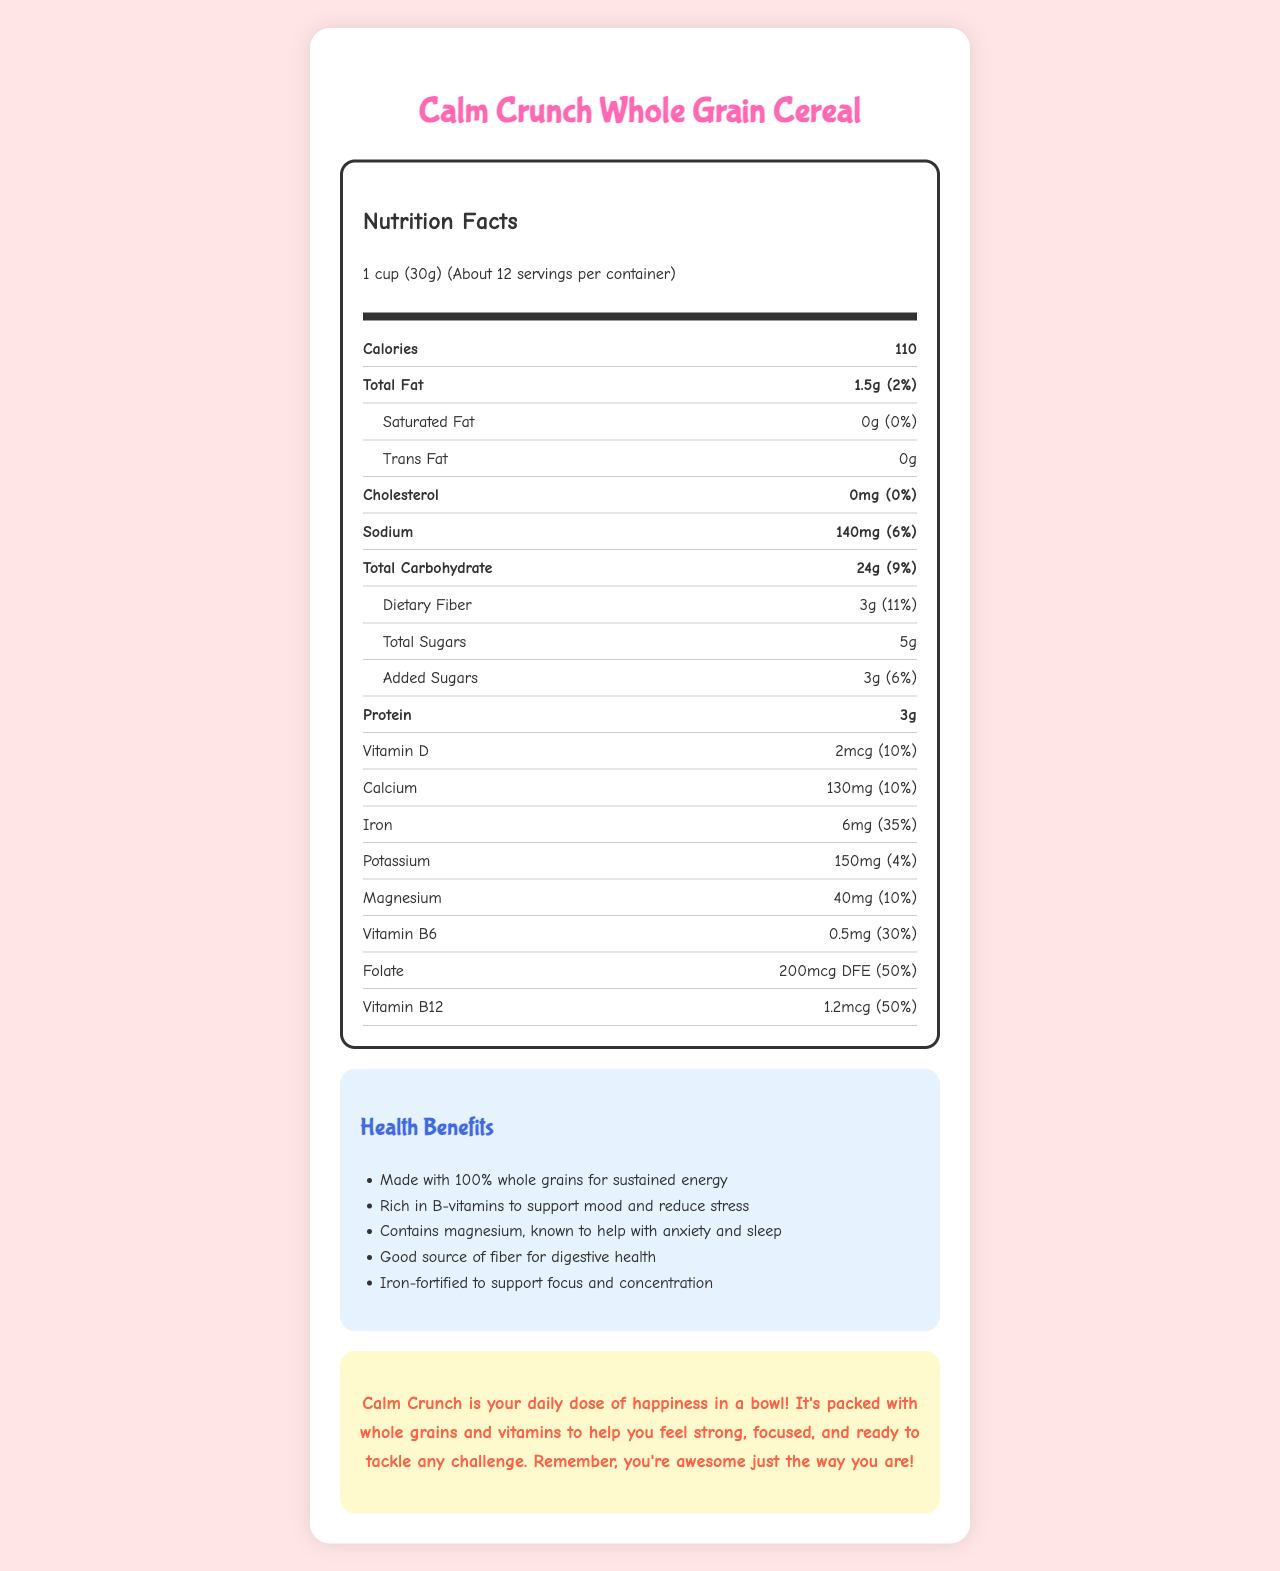who is the cereal made for? The cereal has a "kid-friendly message" that encourages kids by saying they are awesome just the way they are.
Answer: Kids what is the serving size for Calm Crunch Whole Grain Cereal? The serving size is mentioned at the top of the Nutrition Facts label: "1 cup (30g)".
Answer: 1 cup (30g) how many calories are in one serving? The number of calories is listed in bold on the Nutrition Facts label: "Calories 110".
Answer: 110 what percentage of the Daily Value is the iron content? The iron content is listed with its daily value: "Iron 6mg (35%)".
Answer: 35% how much vitamin B12 does one serving provide? The vitamin B12 content is mentioned with its daily value in the Nutrition Facts: "Vitamin B12 1.2mcg (50%)".
Answer: 1.2mcg what is the main ingredient in the cereal? A. Honey B. Cane sugar C. Whole grain oats D. Brown rice The main ingredient is listed first in the list of ingredients: "Whole grain oats".
Answer: C. Whole grain oats which vitamin or mineral has the highest daily value percentage? A. Vitamin B12 B. Folate C. Iron D. Magnesium Among the mentioned vitamins and minerals, folate has the highest daily value percentage: "Folate 200mcg DFE (50%)".
Answer: B. Folate is there any cholesterol in the cereal? The Nutrition Facts label indicates that the cereal contains "0mg" of cholesterol and "0%" of the daily value.
Answer: No what are the health benefits of Calm Crunch Whole Grain Cereal? The health benefits section lists these benefits: made with 100% whole grains for sustained energy, rich in B-vitamins to support mood and reduce stress, contains magnesium, known to help with anxiety and sleep, good source of fiber for digestive health, and iron-fortified to support focus and concentration.
Answer: It is made with 100% whole grains, rich in B-vitamins, contains magnesium, is a good source of fiber, and is iron-fortified. what message does the cereal give to kids? The kid-friendly message at the bottom encourages kids with positive words about their strength, focus, and awesomeness.
Answer: Calm Crunch is your daily dose of happiness in a bowl! It's packed with whole grains and vitamins to help you feel strong, focused, and ready to tackle any challenge. Remember, you're awesome just the way you are! how much protein is in each serving? The protein content is listed in the Nutrition Facts: "Protein 3g".
Answer: 3g what allergens are mentioned for the cereal? The allergen information at the end of the ingredients list mentions wheat and possible traces of nuts and soy.
Answer: Contains wheat. May contain traces of nuts and soy. is this cereal supposed to help with mental well-being? The health benefits section mentions that the cereal is rich in B-vitamins to support mood, reduce stress, and contains magnesium to help with anxiety and sleep.
Answer: Yes how many servings are there in a container? The document states that there are about 12 servings per container.
Answer: About 12 does the cereal contain any magnesium? The Nutrition Facts label shows that the cereal contains 40mg of magnesium (10% daily value).
Answer: Yes what is the main idea of the document? The document thoroughly lists not only the nutrient content and daily values but also the specific health benefits aimed at supporting emotional well-being and overall health for children.
Answer: The document provides nutritional information for Calm Crunch Whole Grain Cereal, emphasizing its health benefits, such as whole grains for energy, vitamins and minerals for emotional well-being, fiber for digestive health, and a positive message for kids. what is the flavor of the cereal? The document mentions natural flavors but does not specify a particular flavor for the cereal.
Answer: Not enough information 